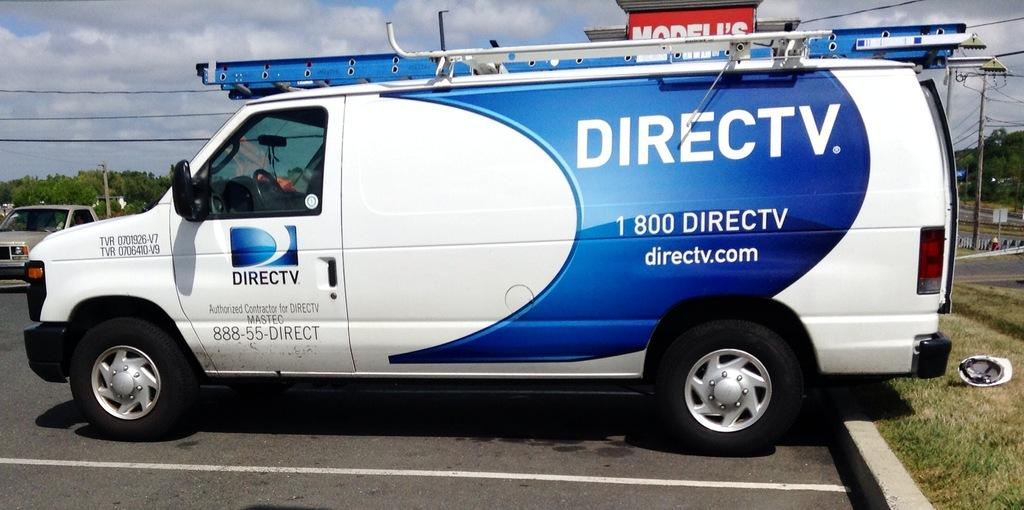<image>
Relay a brief, clear account of the picture shown. Parked in a parking lot is a DIRECT T.V. service truck colors are blue and white. 